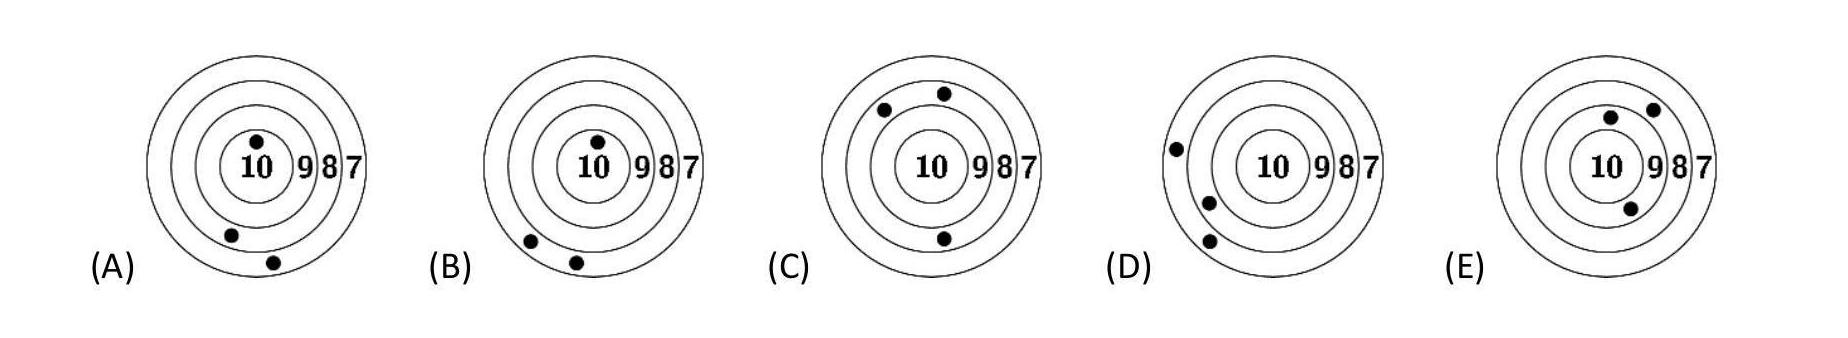Five boys competed in a shooting challenge. Ricky scored the most points. Which target was Ricky's? Based on the image of the targets, Ricky's target is 'E'. This is evident because the shots on target 'E' are closest to the center, achieving the highest score visibly compared to other targets. 